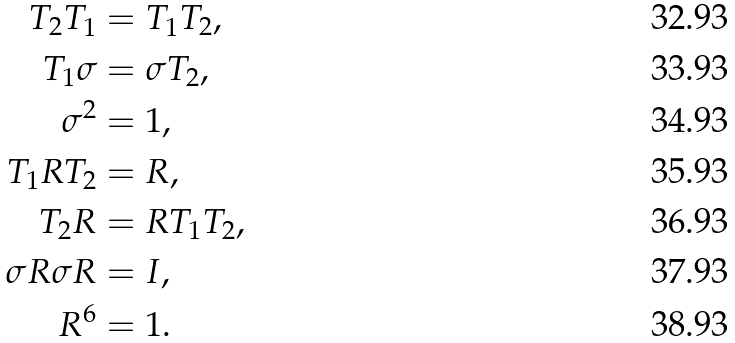<formula> <loc_0><loc_0><loc_500><loc_500>T _ { 2 } T _ { 1 } & = T _ { 1 } T _ { 2 } , \\ T _ { 1 } \sigma & = \sigma T _ { 2 } , \\ \sigma ^ { 2 } & = 1 , \\ T _ { 1 } R T _ { 2 } & = R , \\ T _ { 2 } R & = R T _ { 1 } T _ { 2 } , \\ \sigma R \sigma R & = I , \\ R ^ { 6 } & = 1 .</formula> 